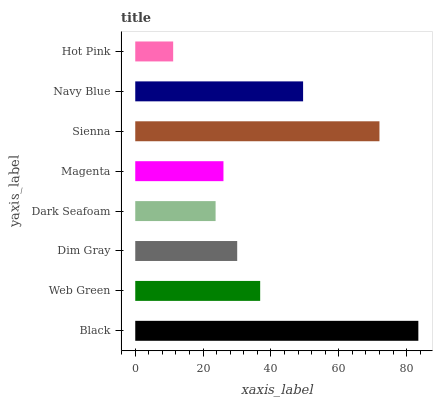Is Hot Pink the minimum?
Answer yes or no. Yes. Is Black the maximum?
Answer yes or no. Yes. Is Web Green the minimum?
Answer yes or no. No. Is Web Green the maximum?
Answer yes or no. No. Is Black greater than Web Green?
Answer yes or no. Yes. Is Web Green less than Black?
Answer yes or no. Yes. Is Web Green greater than Black?
Answer yes or no. No. Is Black less than Web Green?
Answer yes or no. No. Is Web Green the high median?
Answer yes or no. Yes. Is Dim Gray the low median?
Answer yes or no. Yes. Is Dim Gray the high median?
Answer yes or no. No. Is Web Green the low median?
Answer yes or no. No. 